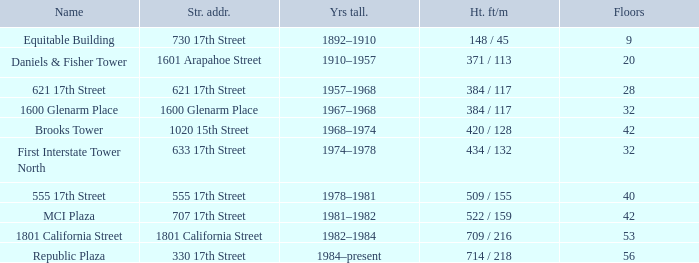What is the height of the building with 40 floors? 509 / 155. I'm looking to parse the entire table for insights. Could you assist me with that? {'header': ['Name', 'Str. addr.', 'Yrs tall.', 'Ht. ft/m', 'Floors'], 'rows': [['Equitable Building', '730 17th Street', '1892–1910', '148 / 45', '9'], ['Daniels & Fisher Tower', '1601 Arapahoe Street', '1910–1957', '371 / 113', '20'], ['621 17th Street', '621 17th Street', '1957–1968', '384 / 117', '28'], ['1600 Glenarm Place', '1600 Glenarm Place', '1967–1968', '384 / 117', '32'], ['Brooks Tower', '1020 15th Street', '1968–1974', '420 / 128', '42'], ['First Interstate Tower North', '633 17th Street', '1974–1978', '434 / 132', '32'], ['555 17th Street', '555 17th Street', '1978–1981', '509 / 155', '40'], ['MCI Plaza', '707 17th Street', '1981–1982', '522 / 159', '42'], ['1801 California Street', '1801 California Street', '1982–1984', '709 / 216', '53'], ['Republic Plaza', '330 17th Street', '1984–present', '714 / 218', '56']]} 